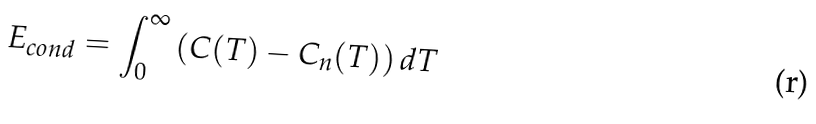<formula> <loc_0><loc_0><loc_500><loc_500>E _ { c o n d } = \int _ { 0 } ^ { \infty } \left ( C ( T ) - C _ { n } ( T ) \right ) d T</formula> 